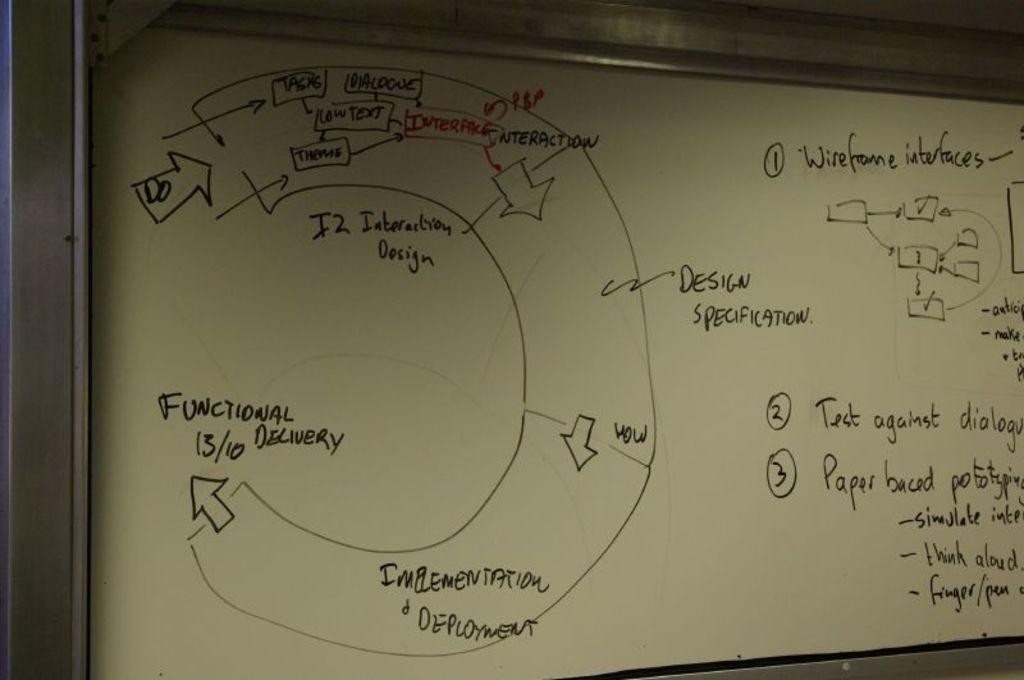<image>
Give a short and clear explanation of the subsequent image. A white board has words and arrows on it all about a design specification. 